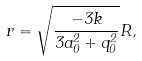Convert formula to latex. <formula><loc_0><loc_0><loc_500><loc_500>r = \sqrt { \frac { - 3 k } { 3 a _ { 0 } ^ { 2 } + q _ { 0 } ^ { 2 } } } R ,</formula> 